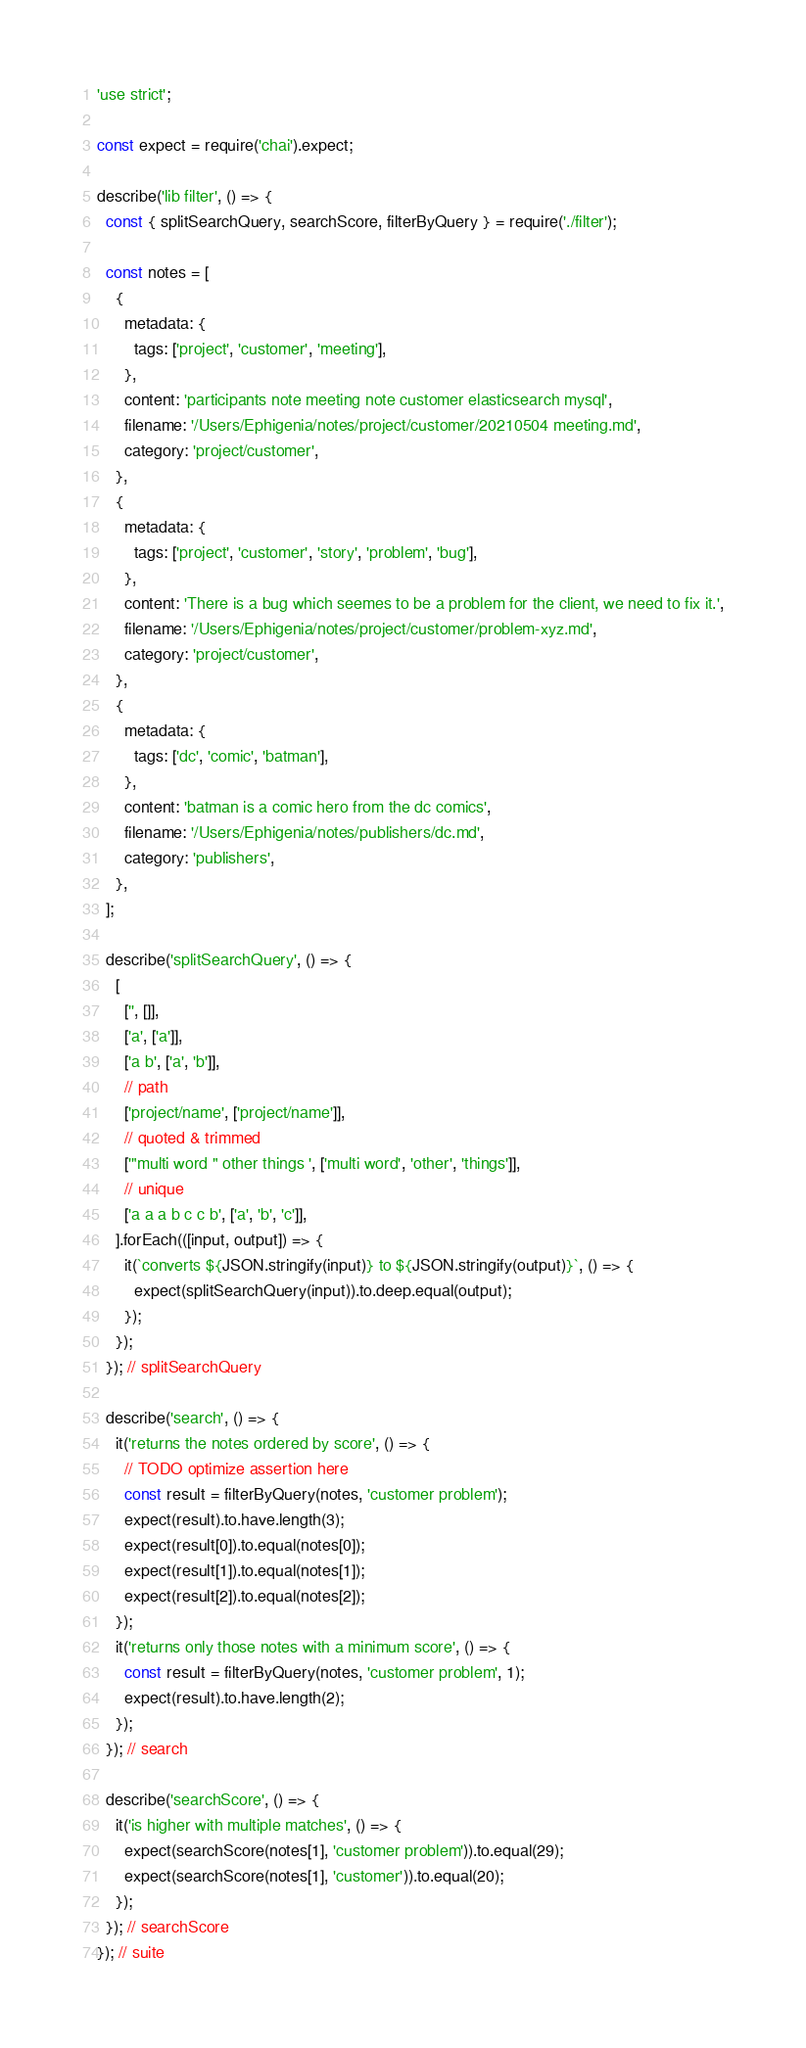<code> <loc_0><loc_0><loc_500><loc_500><_JavaScript_>'use strict';

const expect = require('chai').expect;

describe('lib filter', () => {
  const { splitSearchQuery, searchScore, filterByQuery } = require('./filter');

  const notes = [
    {
      metadata: {
        tags: ['project', 'customer', 'meeting'],
      },
      content: 'participants note meeting note customer elasticsearch mysql',
      filename: '/Users/Ephigenia/notes/project/customer/20210504 meeting.md',
      category: 'project/customer',
    },
    {
      metadata: {
        tags: ['project', 'customer', 'story', 'problem', 'bug'],
      },
      content: 'There is a bug which seemes to be a problem for the client, we need to fix it.',
      filename: '/Users/Ephigenia/notes/project/customer/problem-xyz.md',
      category: 'project/customer',
    },
    {
      metadata: {
        tags: ['dc', 'comic', 'batman'],
      },
      content: 'batman is a comic hero from the dc comics',
      filename: '/Users/Ephigenia/notes/publishers/dc.md',
      category: 'publishers',
    },
  ];

  describe('splitSearchQuery', () => {
    [
      ['', []],
      ['a', ['a']],
      ['a b', ['a', 'b']],
      // path
      ['project/name', ['project/name']],
      // quoted & trimmed
      ['"multi word " other things ', ['multi word', 'other', 'things']],
      // unique
      ['a a a b c c b', ['a', 'b', 'c']],
    ].forEach(([input, output]) => {
      it(`converts ${JSON.stringify(input)} to ${JSON.stringify(output)}`, () => {
        expect(splitSearchQuery(input)).to.deep.equal(output);
      });
    });
  }); // splitSearchQuery

  describe('search', () => {
    it('returns the notes ordered by score', () => {
      // TODO optimize assertion here
      const result = filterByQuery(notes, 'customer problem');
      expect(result).to.have.length(3);
      expect(result[0]).to.equal(notes[0]);
      expect(result[1]).to.equal(notes[1]);
      expect(result[2]).to.equal(notes[2]);
    });
    it('returns only those notes with a minimum score', () => {
      const result = filterByQuery(notes, 'customer problem', 1);
      expect(result).to.have.length(2);
    });
  }); // search

  describe('searchScore', () => {
    it('is higher with multiple matches', () => {
      expect(searchScore(notes[1], 'customer problem')).to.equal(29);
      expect(searchScore(notes[1], 'customer')).to.equal(20);
    });
  }); // searchScore
}); // suite
</code> 